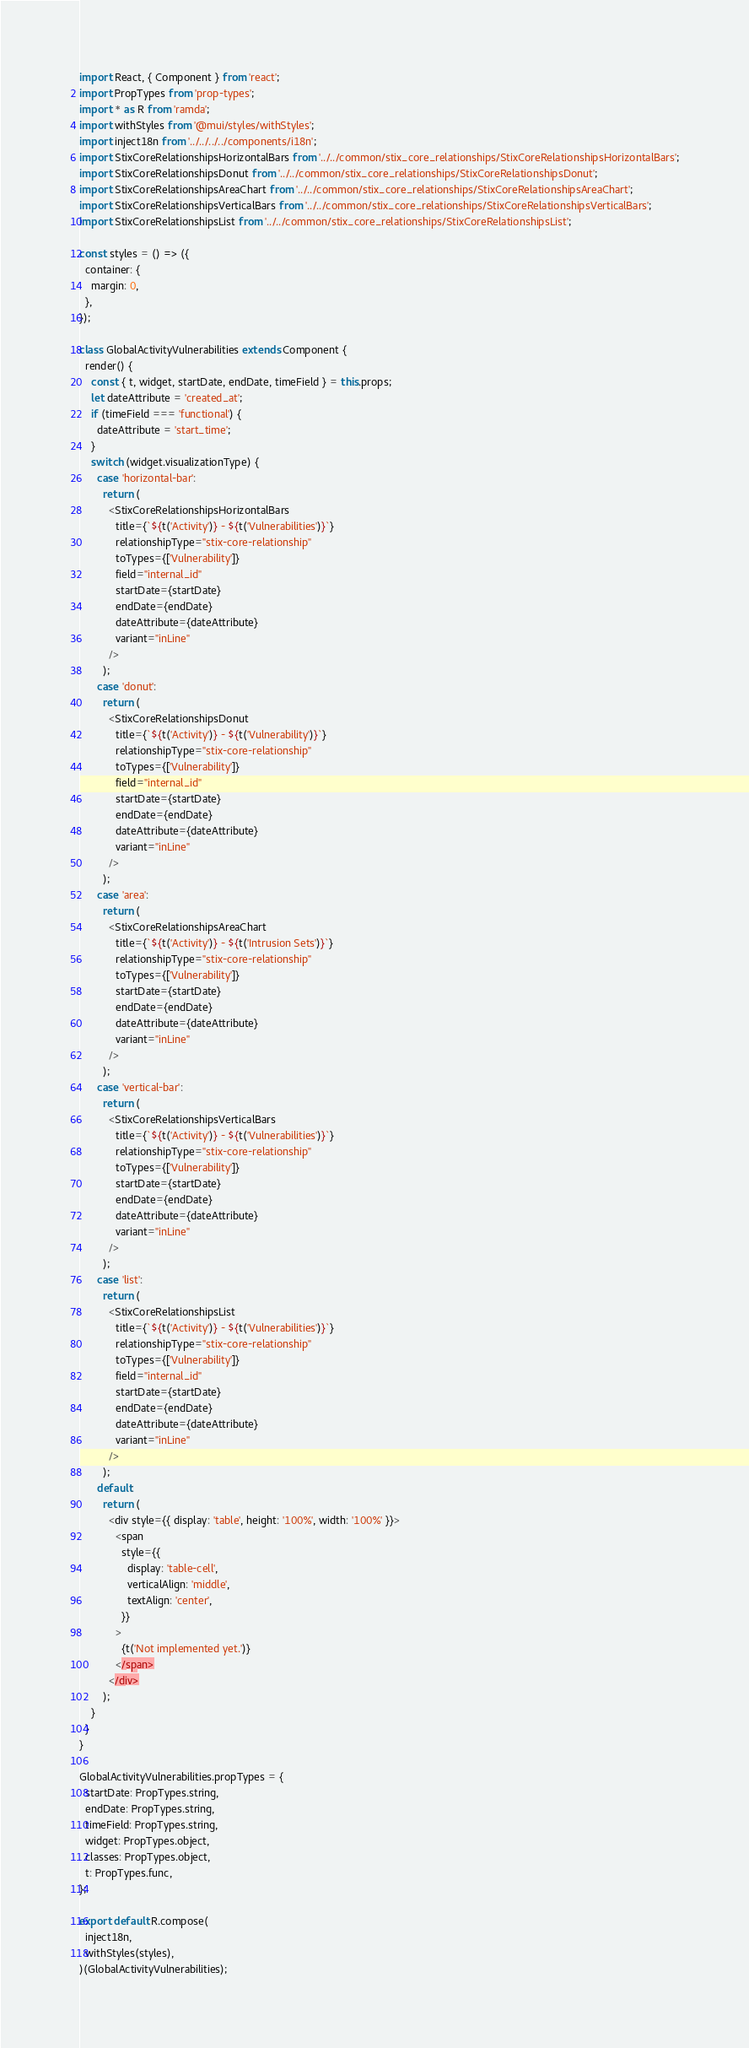<code> <loc_0><loc_0><loc_500><loc_500><_JavaScript_>import React, { Component } from 'react';
import PropTypes from 'prop-types';
import * as R from 'ramda';
import withStyles from '@mui/styles/withStyles';
import inject18n from '../../../../components/i18n';
import StixCoreRelationshipsHorizontalBars from '../../common/stix_core_relationships/StixCoreRelationshipsHorizontalBars';
import StixCoreRelationshipsDonut from '../../common/stix_core_relationships/StixCoreRelationshipsDonut';
import StixCoreRelationshipsAreaChart from '../../common/stix_core_relationships/StixCoreRelationshipsAreaChart';
import StixCoreRelationshipsVerticalBars from '../../common/stix_core_relationships/StixCoreRelationshipsVerticalBars';
import StixCoreRelationshipsList from '../../common/stix_core_relationships/StixCoreRelationshipsList';

const styles = () => ({
  container: {
    margin: 0,
  },
});

class GlobalActivityVulnerabilities extends Component {
  render() {
    const { t, widget, startDate, endDate, timeField } = this.props;
    let dateAttribute = 'created_at';
    if (timeField === 'functional') {
      dateAttribute = 'start_time';
    }
    switch (widget.visualizationType) {
      case 'horizontal-bar':
        return (
          <StixCoreRelationshipsHorizontalBars
            title={`${t('Activity')} - ${t('Vulnerabilities')}`}
            relationshipType="stix-core-relationship"
            toTypes={['Vulnerability']}
            field="internal_id"
            startDate={startDate}
            endDate={endDate}
            dateAttribute={dateAttribute}
            variant="inLine"
          />
        );
      case 'donut':
        return (
          <StixCoreRelationshipsDonut
            title={`${t('Activity')} - ${t('Vulnerability')}`}
            relationshipType="stix-core-relationship"
            toTypes={['Vulnerability']}
            field="internal_id"
            startDate={startDate}
            endDate={endDate}
            dateAttribute={dateAttribute}
            variant="inLine"
          />
        );
      case 'area':
        return (
          <StixCoreRelationshipsAreaChart
            title={`${t('Activity')} - ${t('Intrusion Sets')}`}
            relationshipType="stix-core-relationship"
            toTypes={['Vulnerability']}
            startDate={startDate}
            endDate={endDate}
            dateAttribute={dateAttribute}
            variant="inLine"
          />
        );
      case 'vertical-bar':
        return (
          <StixCoreRelationshipsVerticalBars
            title={`${t('Activity')} - ${t('Vulnerabilities')}`}
            relationshipType="stix-core-relationship"
            toTypes={['Vulnerability']}
            startDate={startDate}
            endDate={endDate}
            dateAttribute={dateAttribute}
            variant="inLine"
          />
        );
      case 'list':
        return (
          <StixCoreRelationshipsList
            title={`${t('Activity')} - ${t('Vulnerabilities')}`}
            relationshipType="stix-core-relationship"
            toTypes={['Vulnerability']}
            field="internal_id"
            startDate={startDate}
            endDate={endDate}
            dateAttribute={dateAttribute}
            variant="inLine"
          />
        );
      default:
        return (
          <div style={{ display: 'table', height: '100%', width: '100%' }}>
            <span
              style={{
                display: 'table-cell',
                verticalAlign: 'middle',
                textAlign: 'center',
              }}
            >
              {t('Not implemented yet.')}
            </span>
          </div>
        );
    }
  }
}

GlobalActivityVulnerabilities.propTypes = {
  startDate: PropTypes.string,
  endDate: PropTypes.string,
  timeField: PropTypes.string,
  widget: PropTypes.object,
  classes: PropTypes.object,
  t: PropTypes.func,
};

export default R.compose(
  inject18n,
  withStyles(styles),
)(GlobalActivityVulnerabilities);
</code> 